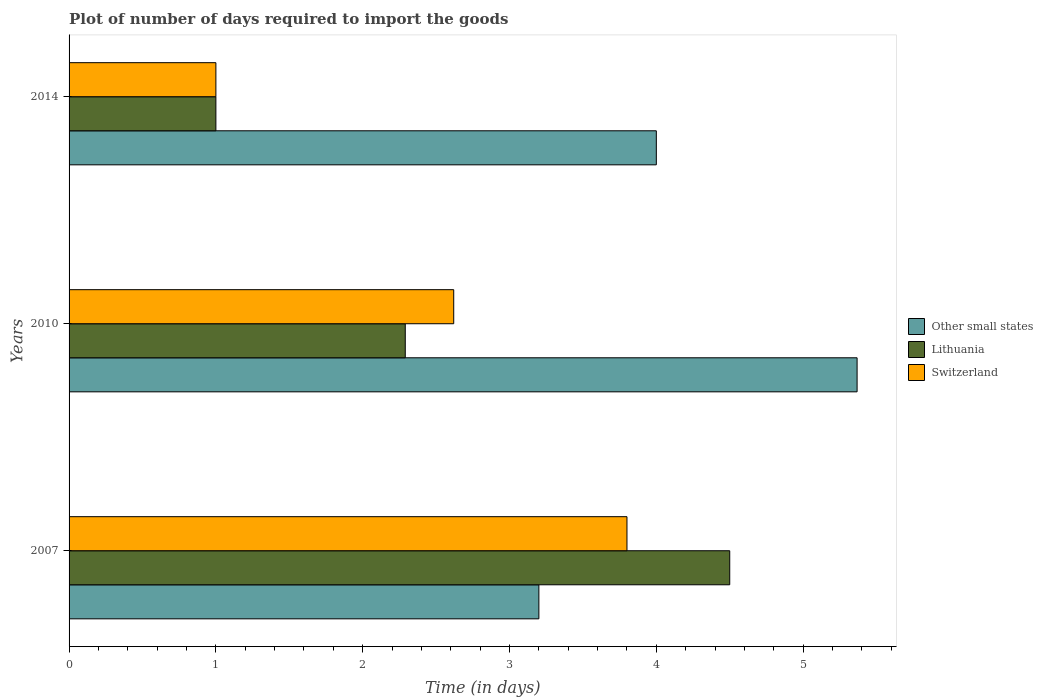How many bars are there on the 1st tick from the bottom?
Your answer should be very brief. 3. What is the label of the 1st group of bars from the top?
Offer a very short reply. 2014. Across all years, what is the minimum time required to import goods in Switzerland?
Keep it short and to the point. 1. In which year was the time required to import goods in Lithuania minimum?
Ensure brevity in your answer.  2014. What is the total time required to import goods in Switzerland in the graph?
Ensure brevity in your answer.  7.42. What is the difference between the time required to import goods in Switzerland in 2007 and that in 2014?
Ensure brevity in your answer.  2.8. What is the difference between the time required to import goods in Other small states in 2010 and the time required to import goods in Switzerland in 2007?
Your response must be concise. 1.57. What is the average time required to import goods in Switzerland per year?
Your answer should be compact. 2.47. In the year 2007, what is the difference between the time required to import goods in Lithuania and time required to import goods in Switzerland?
Offer a very short reply. 0.7. What is the ratio of the time required to import goods in Switzerland in 2007 to that in 2014?
Your answer should be very brief. 3.8. Is the time required to import goods in Other small states in 2007 less than that in 2010?
Give a very brief answer. Yes. Is the difference between the time required to import goods in Lithuania in 2007 and 2010 greater than the difference between the time required to import goods in Switzerland in 2007 and 2010?
Provide a short and direct response. Yes. What is the difference between the highest and the second highest time required to import goods in Switzerland?
Your answer should be very brief. 1.18. What is the difference between the highest and the lowest time required to import goods in Other small states?
Offer a terse response. 2.17. Is the sum of the time required to import goods in Other small states in 2010 and 2014 greater than the maximum time required to import goods in Switzerland across all years?
Keep it short and to the point. Yes. What does the 2nd bar from the top in 2010 represents?
Your answer should be very brief. Lithuania. What does the 1st bar from the bottom in 2014 represents?
Your answer should be compact. Other small states. Is it the case that in every year, the sum of the time required to import goods in Switzerland and time required to import goods in Other small states is greater than the time required to import goods in Lithuania?
Ensure brevity in your answer.  Yes. How many bars are there?
Your answer should be compact. 9. Are all the bars in the graph horizontal?
Keep it short and to the point. Yes. How many years are there in the graph?
Your answer should be compact. 3. Are the values on the major ticks of X-axis written in scientific E-notation?
Keep it short and to the point. No. What is the title of the graph?
Make the answer very short. Plot of number of days required to import the goods. What is the label or title of the X-axis?
Provide a short and direct response. Time (in days). What is the label or title of the Y-axis?
Your answer should be very brief. Years. What is the Time (in days) of Other small states in 2007?
Make the answer very short. 3.2. What is the Time (in days) of Lithuania in 2007?
Your response must be concise. 4.5. What is the Time (in days) of Switzerland in 2007?
Your response must be concise. 3.8. What is the Time (in days) in Other small states in 2010?
Your answer should be very brief. 5.37. What is the Time (in days) in Lithuania in 2010?
Give a very brief answer. 2.29. What is the Time (in days) in Switzerland in 2010?
Offer a very short reply. 2.62. What is the Time (in days) in Lithuania in 2014?
Your answer should be compact. 1. What is the Time (in days) in Switzerland in 2014?
Your answer should be compact. 1. Across all years, what is the maximum Time (in days) of Other small states?
Make the answer very short. 5.37. Across all years, what is the minimum Time (in days) of Lithuania?
Offer a terse response. 1. Across all years, what is the minimum Time (in days) of Switzerland?
Provide a succinct answer. 1. What is the total Time (in days) in Other small states in the graph?
Give a very brief answer. 12.57. What is the total Time (in days) in Lithuania in the graph?
Provide a short and direct response. 7.79. What is the total Time (in days) in Switzerland in the graph?
Ensure brevity in your answer.  7.42. What is the difference between the Time (in days) in Other small states in 2007 and that in 2010?
Give a very brief answer. -2.17. What is the difference between the Time (in days) in Lithuania in 2007 and that in 2010?
Provide a succinct answer. 2.21. What is the difference between the Time (in days) of Switzerland in 2007 and that in 2010?
Ensure brevity in your answer.  1.18. What is the difference between the Time (in days) in Other small states in 2007 and that in 2014?
Offer a very short reply. -0.8. What is the difference between the Time (in days) of Switzerland in 2007 and that in 2014?
Provide a succinct answer. 2.8. What is the difference between the Time (in days) of Other small states in 2010 and that in 2014?
Provide a succinct answer. 1.37. What is the difference between the Time (in days) of Lithuania in 2010 and that in 2014?
Your response must be concise. 1.29. What is the difference between the Time (in days) in Switzerland in 2010 and that in 2014?
Give a very brief answer. 1.62. What is the difference between the Time (in days) of Other small states in 2007 and the Time (in days) of Lithuania in 2010?
Provide a short and direct response. 0.91. What is the difference between the Time (in days) of Other small states in 2007 and the Time (in days) of Switzerland in 2010?
Provide a short and direct response. 0.58. What is the difference between the Time (in days) of Lithuania in 2007 and the Time (in days) of Switzerland in 2010?
Your answer should be very brief. 1.88. What is the difference between the Time (in days) in Lithuania in 2007 and the Time (in days) in Switzerland in 2014?
Offer a very short reply. 3.5. What is the difference between the Time (in days) in Other small states in 2010 and the Time (in days) in Lithuania in 2014?
Ensure brevity in your answer.  4.37. What is the difference between the Time (in days) of Other small states in 2010 and the Time (in days) of Switzerland in 2014?
Offer a very short reply. 4.37. What is the difference between the Time (in days) of Lithuania in 2010 and the Time (in days) of Switzerland in 2014?
Keep it short and to the point. 1.29. What is the average Time (in days) in Other small states per year?
Keep it short and to the point. 4.19. What is the average Time (in days) of Lithuania per year?
Your response must be concise. 2.6. What is the average Time (in days) of Switzerland per year?
Offer a terse response. 2.47. In the year 2007, what is the difference between the Time (in days) in Other small states and Time (in days) in Lithuania?
Make the answer very short. -1.3. In the year 2010, what is the difference between the Time (in days) in Other small states and Time (in days) in Lithuania?
Give a very brief answer. 3.08. In the year 2010, what is the difference between the Time (in days) of Other small states and Time (in days) of Switzerland?
Make the answer very short. 2.75. In the year 2010, what is the difference between the Time (in days) of Lithuania and Time (in days) of Switzerland?
Ensure brevity in your answer.  -0.33. In the year 2014, what is the difference between the Time (in days) in Other small states and Time (in days) in Lithuania?
Offer a terse response. 3. In the year 2014, what is the difference between the Time (in days) in Other small states and Time (in days) in Switzerland?
Keep it short and to the point. 3. What is the ratio of the Time (in days) in Other small states in 2007 to that in 2010?
Make the answer very short. 0.6. What is the ratio of the Time (in days) of Lithuania in 2007 to that in 2010?
Offer a very short reply. 1.97. What is the ratio of the Time (in days) of Switzerland in 2007 to that in 2010?
Your answer should be very brief. 1.45. What is the ratio of the Time (in days) in Other small states in 2007 to that in 2014?
Offer a very short reply. 0.8. What is the ratio of the Time (in days) of Switzerland in 2007 to that in 2014?
Your answer should be very brief. 3.8. What is the ratio of the Time (in days) of Other small states in 2010 to that in 2014?
Give a very brief answer. 1.34. What is the ratio of the Time (in days) in Lithuania in 2010 to that in 2014?
Your answer should be compact. 2.29. What is the ratio of the Time (in days) in Switzerland in 2010 to that in 2014?
Your answer should be very brief. 2.62. What is the difference between the highest and the second highest Time (in days) of Other small states?
Give a very brief answer. 1.37. What is the difference between the highest and the second highest Time (in days) of Lithuania?
Give a very brief answer. 2.21. What is the difference between the highest and the second highest Time (in days) of Switzerland?
Keep it short and to the point. 1.18. What is the difference between the highest and the lowest Time (in days) in Other small states?
Ensure brevity in your answer.  2.17. 